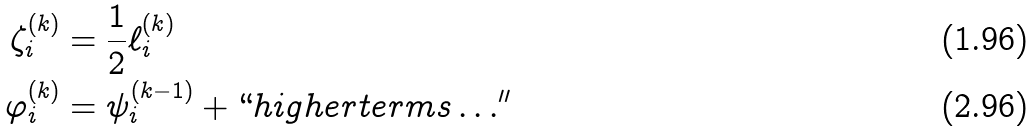<formula> <loc_0><loc_0><loc_500><loc_500>\zeta _ { i } ^ { ( k ) } & = \frac { 1 } { 2 } \ell _ { i } ^ { ( k ) } \\ \varphi _ { i } ^ { ( k ) } & = \psi _ { i } ^ { ( k - 1 ) } + ` ` h i g h e r t e r m s \dots ^ { \prime \prime }</formula> 